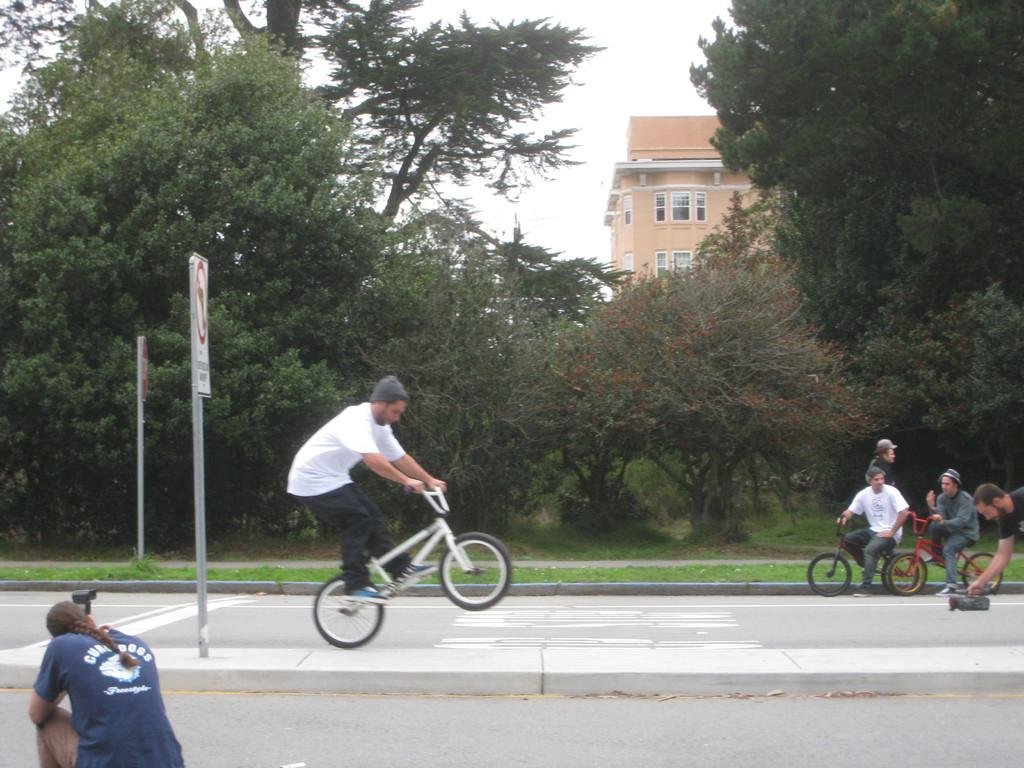What are the people in the image doing? The people in the image are riding bicycles on the road. Can you describe the woman's position in the image? The woman is sitting on the left side. What can be seen in the background of the image? There are trees, a building, and the sky visible in the background. What type of magic is being performed by the people riding bicycles in the image? There is no magic being performed in the image; the people are simply riding bicycles. Can you describe the vest worn by the truck in the image? There is no truck present in the image, and therefore no vest to describe. 